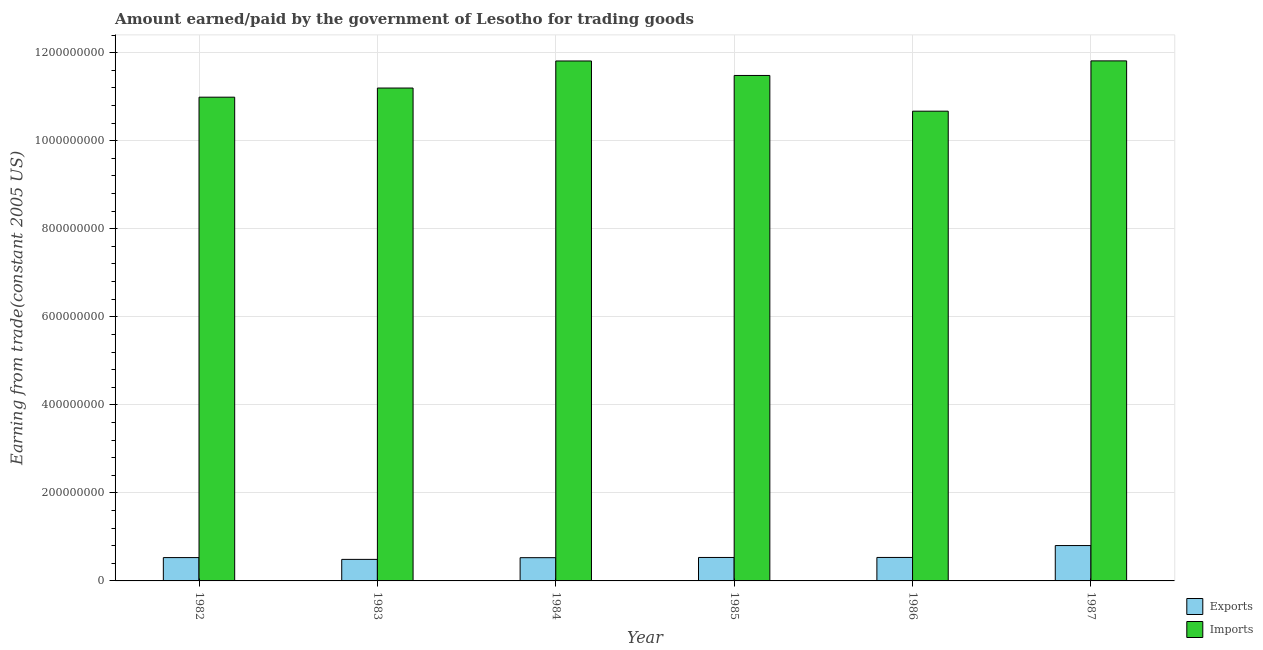How many groups of bars are there?
Keep it short and to the point. 6. Are the number of bars on each tick of the X-axis equal?
Ensure brevity in your answer.  Yes. How many bars are there on the 2nd tick from the left?
Your response must be concise. 2. How many bars are there on the 4th tick from the right?
Your answer should be compact. 2. What is the amount paid for imports in 1984?
Make the answer very short. 1.18e+09. Across all years, what is the maximum amount paid for imports?
Provide a short and direct response. 1.18e+09. Across all years, what is the minimum amount paid for imports?
Provide a short and direct response. 1.07e+09. In which year was the amount earned from exports maximum?
Your answer should be very brief. 1987. In which year was the amount earned from exports minimum?
Offer a terse response. 1983. What is the total amount earned from exports in the graph?
Make the answer very short. 3.42e+08. What is the difference between the amount earned from exports in 1982 and that in 1983?
Keep it short and to the point. 4.11e+06. What is the difference between the amount paid for imports in 1985 and the amount earned from exports in 1986?
Offer a terse response. 8.11e+07. What is the average amount paid for imports per year?
Offer a terse response. 1.13e+09. What is the ratio of the amount earned from exports in 1982 to that in 1987?
Give a very brief answer. 0.66. Is the amount paid for imports in 1983 less than that in 1985?
Your answer should be very brief. Yes. Is the difference between the amount paid for imports in 1986 and 1987 greater than the difference between the amount earned from exports in 1986 and 1987?
Your response must be concise. No. What is the difference between the highest and the second highest amount paid for imports?
Keep it short and to the point. 2.28e+05. What is the difference between the highest and the lowest amount paid for imports?
Make the answer very short. 1.14e+08. What does the 1st bar from the left in 1984 represents?
Keep it short and to the point. Exports. What does the 1st bar from the right in 1982 represents?
Provide a short and direct response. Imports. How many bars are there?
Keep it short and to the point. 12. What is the difference between two consecutive major ticks on the Y-axis?
Offer a very short reply. 2.00e+08. Are the values on the major ticks of Y-axis written in scientific E-notation?
Offer a very short reply. No. Does the graph contain any zero values?
Your answer should be compact. No. Where does the legend appear in the graph?
Provide a succinct answer. Bottom right. How many legend labels are there?
Make the answer very short. 2. What is the title of the graph?
Your response must be concise. Amount earned/paid by the government of Lesotho for trading goods. What is the label or title of the Y-axis?
Offer a very short reply. Earning from trade(constant 2005 US). What is the Earning from trade(constant 2005 US) in Exports in 1982?
Make the answer very short. 5.30e+07. What is the Earning from trade(constant 2005 US) in Imports in 1982?
Offer a very short reply. 1.10e+09. What is the Earning from trade(constant 2005 US) of Exports in 1983?
Your answer should be compact. 4.89e+07. What is the Earning from trade(constant 2005 US) in Imports in 1983?
Give a very brief answer. 1.12e+09. What is the Earning from trade(constant 2005 US) of Exports in 1984?
Give a very brief answer. 5.28e+07. What is the Earning from trade(constant 2005 US) in Imports in 1984?
Give a very brief answer. 1.18e+09. What is the Earning from trade(constant 2005 US) of Exports in 1985?
Make the answer very short. 5.33e+07. What is the Earning from trade(constant 2005 US) in Imports in 1985?
Make the answer very short. 1.15e+09. What is the Earning from trade(constant 2005 US) of Exports in 1986?
Your answer should be very brief. 5.33e+07. What is the Earning from trade(constant 2005 US) of Imports in 1986?
Your response must be concise. 1.07e+09. What is the Earning from trade(constant 2005 US) of Exports in 1987?
Offer a terse response. 8.04e+07. What is the Earning from trade(constant 2005 US) in Imports in 1987?
Offer a very short reply. 1.18e+09. Across all years, what is the maximum Earning from trade(constant 2005 US) of Exports?
Provide a short and direct response. 8.04e+07. Across all years, what is the maximum Earning from trade(constant 2005 US) of Imports?
Offer a terse response. 1.18e+09. Across all years, what is the minimum Earning from trade(constant 2005 US) of Exports?
Keep it short and to the point. 4.89e+07. Across all years, what is the minimum Earning from trade(constant 2005 US) of Imports?
Provide a short and direct response. 1.07e+09. What is the total Earning from trade(constant 2005 US) of Exports in the graph?
Ensure brevity in your answer.  3.42e+08. What is the total Earning from trade(constant 2005 US) in Imports in the graph?
Your answer should be very brief. 6.80e+09. What is the difference between the Earning from trade(constant 2005 US) of Exports in 1982 and that in 1983?
Make the answer very short. 4.11e+06. What is the difference between the Earning from trade(constant 2005 US) of Imports in 1982 and that in 1983?
Offer a very short reply. -2.08e+07. What is the difference between the Earning from trade(constant 2005 US) of Exports in 1982 and that in 1984?
Offer a very short reply. 2.31e+05. What is the difference between the Earning from trade(constant 2005 US) of Imports in 1982 and that in 1984?
Your answer should be compact. -8.22e+07. What is the difference between the Earning from trade(constant 2005 US) of Exports in 1982 and that in 1985?
Keep it short and to the point. -2.81e+05. What is the difference between the Earning from trade(constant 2005 US) in Imports in 1982 and that in 1985?
Offer a very short reply. -4.93e+07. What is the difference between the Earning from trade(constant 2005 US) of Exports in 1982 and that in 1986?
Provide a short and direct response. -3.18e+05. What is the difference between the Earning from trade(constant 2005 US) in Imports in 1982 and that in 1986?
Keep it short and to the point. 3.18e+07. What is the difference between the Earning from trade(constant 2005 US) of Exports in 1982 and that in 1987?
Make the answer very short. -2.73e+07. What is the difference between the Earning from trade(constant 2005 US) in Imports in 1982 and that in 1987?
Your answer should be compact. -8.25e+07. What is the difference between the Earning from trade(constant 2005 US) of Exports in 1983 and that in 1984?
Your answer should be compact. -3.87e+06. What is the difference between the Earning from trade(constant 2005 US) of Imports in 1983 and that in 1984?
Provide a short and direct response. -6.15e+07. What is the difference between the Earning from trade(constant 2005 US) of Exports in 1983 and that in 1985?
Provide a succinct answer. -4.39e+06. What is the difference between the Earning from trade(constant 2005 US) in Imports in 1983 and that in 1985?
Ensure brevity in your answer.  -2.86e+07. What is the difference between the Earning from trade(constant 2005 US) of Exports in 1983 and that in 1986?
Your answer should be very brief. -4.42e+06. What is the difference between the Earning from trade(constant 2005 US) of Imports in 1983 and that in 1986?
Provide a short and direct response. 5.26e+07. What is the difference between the Earning from trade(constant 2005 US) of Exports in 1983 and that in 1987?
Offer a terse response. -3.14e+07. What is the difference between the Earning from trade(constant 2005 US) in Imports in 1983 and that in 1987?
Make the answer very short. -6.17e+07. What is the difference between the Earning from trade(constant 2005 US) in Exports in 1984 and that in 1985?
Offer a terse response. -5.11e+05. What is the difference between the Earning from trade(constant 2005 US) of Imports in 1984 and that in 1985?
Ensure brevity in your answer.  3.29e+07. What is the difference between the Earning from trade(constant 2005 US) in Exports in 1984 and that in 1986?
Give a very brief answer. -5.48e+05. What is the difference between the Earning from trade(constant 2005 US) in Imports in 1984 and that in 1986?
Your answer should be very brief. 1.14e+08. What is the difference between the Earning from trade(constant 2005 US) in Exports in 1984 and that in 1987?
Give a very brief answer. -2.76e+07. What is the difference between the Earning from trade(constant 2005 US) in Imports in 1984 and that in 1987?
Provide a succinct answer. -2.28e+05. What is the difference between the Earning from trade(constant 2005 US) of Exports in 1985 and that in 1986?
Make the answer very short. -3.70e+04. What is the difference between the Earning from trade(constant 2005 US) of Imports in 1985 and that in 1986?
Offer a very short reply. 8.11e+07. What is the difference between the Earning from trade(constant 2005 US) of Exports in 1985 and that in 1987?
Ensure brevity in your answer.  -2.70e+07. What is the difference between the Earning from trade(constant 2005 US) in Imports in 1985 and that in 1987?
Ensure brevity in your answer.  -3.31e+07. What is the difference between the Earning from trade(constant 2005 US) in Exports in 1986 and that in 1987?
Provide a succinct answer. -2.70e+07. What is the difference between the Earning from trade(constant 2005 US) in Imports in 1986 and that in 1987?
Offer a very short reply. -1.14e+08. What is the difference between the Earning from trade(constant 2005 US) of Exports in 1982 and the Earning from trade(constant 2005 US) of Imports in 1983?
Make the answer very short. -1.07e+09. What is the difference between the Earning from trade(constant 2005 US) in Exports in 1982 and the Earning from trade(constant 2005 US) in Imports in 1984?
Offer a very short reply. -1.13e+09. What is the difference between the Earning from trade(constant 2005 US) of Exports in 1982 and the Earning from trade(constant 2005 US) of Imports in 1985?
Your answer should be compact. -1.10e+09. What is the difference between the Earning from trade(constant 2005 US) in Exports in 1982 and the Earning from trade(constant 2005 US) in Imports in 1986?
Give a very brief answer. -1.01e+09. What is the difference between the Earning from trade(constant 2005 US) in Exports in 1982 and the Earning from trade(constant 2005 US) in Imports in 1987?
Offer a terse response. -1.13e+09. What is the difference between the Earning from trade(constant 2005 US) of Exports in 1983 and the Earning from trade(constant 2005 US) of Imports in 1984?
Provide a short and direct response. -1.13e+09. What is the difference between the Earning from trade(constant 2005 US) of Exports in 1983 and the Earning from trade(constant 2005 US) of Imports in 1985?
Your answer should be compact. -1.10e+09. What is the difference between the Earning from trade(constant 2005 US) in Exports in 1983 and the Earning from trade(constant 2005 US) in Imports in 1986?
Your response must be concise. -1.02e+09. What is the difference between the Earning from trade(constant 2005 US) of Exports in 1983 and the Earning from trade(constant 2005 US) of Imports in 1987?
Provide a short and direct response. -1.13e+09. What is the difference between the Earning from trade(constant 2005 US) in Exports in 1984 and the Earning from trade(constant 2005 US) in Imports in 1985?
Give a very brief answer. -1.10e+09. What is the difference between the Earning from trade(constant 2005 US) in Exports in 1984 and the Earning from trade(constant 2005 US) in Imports in 1986?
Provide a succinct answer. -1.01e+09. What is the difference between the Earning from trade(constant 2005 US) in Exports in 1984 and the Earning from trade(constant 2005 US) in Imports in 1987?
Your response must be concise. -1.13e+09. What is the difference between the Earning from trade(constant 2005 US) in Exports in 1985 and the Earning from trade(constant 2005 US) in Imports in 1986?
Give a very brief answer. -1.01e+09. What is the difference between the Earning from trade(constant 2005 US) of Exports in 1985 and the Earning from trade(constant 2005 US) of Imports in 1987?
Give a very brief answer. -1.13e+09. What is the difference between the Earning from trade(constant 2005 US) in Exports in 1986 and the Earning from trade(constant 2005 US) in Imports in 1987?
Your answer should be very brief. -1.13e+09. What is the average Earning from trade(constant 2005 US) in Exports per year?
Keep it short and to the point. 5.70e+07. What is the average Earning from trade(constant 2005 US) of Imports per year?
Your answer should be very brief. 1.13e+09. In the year 1982, what is the difference between the Earning from trade(constant 2005 US) in Exports and Earning from trade(constant 2005 US) in Imports?
Provide a short and direct response. -1.05e+09. In the year 1983, what is the difference between the Earning from trade(constant 2005 US) of Exports and Earning from trade(constant 2005 US) of Imports?
Your answer should be very brief. -1.07e+09. In the year 1984, what is the difference between the Earning from trade(constant 2005 US) of Exports and Earning from trade(constant 2005 US) of Imports?
Give a very brief answer. -1.13e+09. In the year 1985, what is the difference between the Earning from trade(constant 2005 US) of Exports and Earning from trade(constant 2005 US) of Imports?
Offer a very short reply. -1.09e+09. In the year 1986, what is the difference between the Earning from trade(constant 2005 US) in Exports and Earning from trade(constant 2005 US) in Imports?
Your answer should be very brief. -1.01e+09. In the year 1987, what is the difference between the Earning from trade(constant 2005 US) in Exports and Earning from trade(constant 2005 US) in Imports?
Your answer should be very brief. -1.10e+09. What is the ratio of the Earning from trade(constant 2005 US) in Exports in 1982 to that in 1983?
Provide a short and direct response. 1.08. What is the ratio of the Earning from trade(constant 2005 US) of Imports in 1982 to that in 1983?
Ensure brevity in your answer.  0.98. What is the ratio of the Earning from trade(constant 2005 US) in Imports in 1982 to that in 1984?
Make the answer very short. 0.93. What is the ratio of the Earning from trade(constant 2005 US) in Imports in 1982 to that in 1985?
Ensure brevity in your answer.  0.96. What is the ratio of the Earning from trade(constant 2005 US) in Imports in 1982 to that in 1986?
Your response must be concise. 1.03. What is the ratio of the Earning from trade(constant 2005 US) in Exports in 1982 to that in 1987?
Your response must be concise. 0.66. What is the ratio of the Earning from trade(constant 2005 US) in Imports in 1982 to that in 1987?
Ensure brevity in your answer.  0.93. What is the ratio of the Earning from trade(constant 2005 US) in Exports in 1983 to that in 1984?
Make the answer very short. 0.93. What is the ratio of the Earning from trade(constant 2005 US) of Imports in 1983 to that in 1984?
Ensure brevity in your answer.  0.95. What is the ratio of the Earning from trade(constant 2005 US) in Exports in 1983 to that in 1985?
Keep it short and to the point. 0.92. What is the ratio of the Earning from trade(constant 2005 US) in Imports in 1983 to that in 1985?
Your answer should be compact. 0.98. What is the ratio of the Earning from trade(constant 2005 US) of Exports in 1983 to that in 1986?
Ensure brevity in your answer.  0.92. What is the ratio of the Earning from trade(constant 2005 US) of Imports in 1983 to that in 1986?
Make the answer very short. 1.05. What is the ratio of the Earning from trade(constant 2005 US) of Exports in 1983 to that in 1987?
Provide a succinct answer. 0.61. What is the ratio of the Earning from trade(constant 2005 US) of Imports in 1983 to that in 1987?
Provide a short and direct response. 0.95. What is the ratio of the Earning from trade(constant 2005 US) of Imports in 1984 to that in 1985?
Your answer should be very brief. 1.03. What is the ratio of the Earning from trade(constant 2005 US) of Exports in 1984 to that in 1986?
Make the answer very short. 0.99. What is the ratio of the Earning from trade(constant 2005 US) in Imports in 1984 to that in 1986?
Offer a terse response. 1.11. What is the ratio of the Earning from trade(constant 2005 US) in Exports in 1984 to that in 1987?
Your response must be concise. 0.66. What is the ratio of the Earning from trade(constant 2005 US) in Exports in 1985 to that in 1986?
Offer a terse response. 1. What is the ratio of the Earning from trade(constant 2005 US) in Imports in 1985 to that in 1986?
Provide a short and direct response. 1.08. What is the ratio of the Earning from trade(constant 2005 US) in Exports in 1985 to that in 1987?
Offer a terse response. 0.66. What is the ratio of the Earning from trade(constant 2005 US) in Imports in 1985 to that in 1987?
Offer a terse response. 0.97. What is the ratio of the Earning from trade(constant 2005 US) in Exports in 1986 to that in 1987?
Keep it short and to the point. 0.66. What is the ratio of the Earning from trade(constant 2005 US) in Imports in 1986 to that in 1987?
Ensure brevity in your answer.  0.9. What is the difference between the highest and the second highest Earning from trade(constant 2005 US) of Exports?
Offer a terse response. 2.70e+07. What is the difference between the highest and the second highest Earning from trade(constant 2005 US) in Imports?
Offer a terse response. 2.28e+05. What is the difference between the highest and the lowest Earning from trade(constant 2005 US) of Exports?
Provide a succinct answer. 3.14e+07. What is the difference between the highest and the lowest Earning from trade(constant 2005 US) of Imports?
Provide a short and direct response. 1.14e+08. 